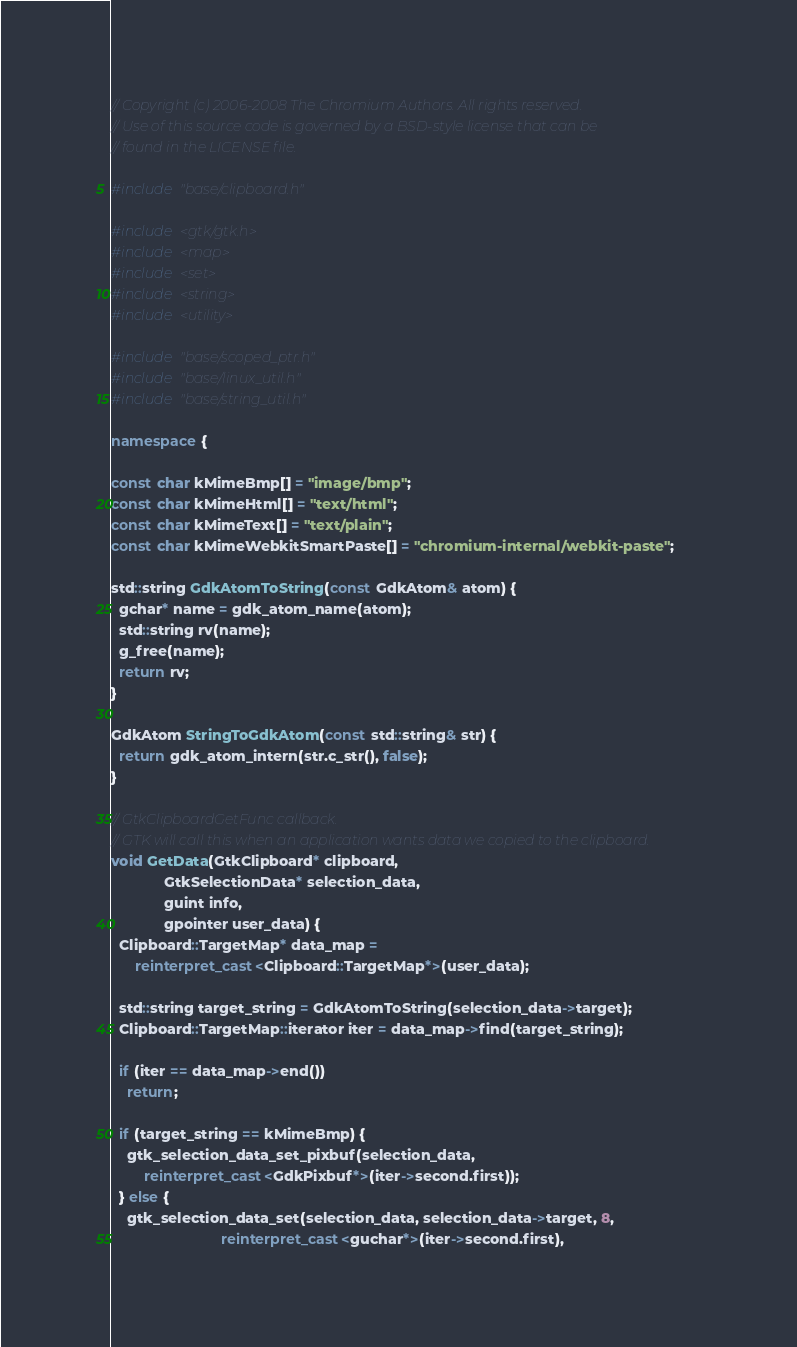<code> <loc_0><loc_0><loc_500><loc_500><_C++_>// Copyright (c) 2006-2008 The Chromium Authors. All rights reserved.
// Use of this source code is governed by a BSD-style license that can be
// found in the LICENSE file.

#include "base/clipboard.h"

#include <gtk/gtk.h>
#include <map>
#include <set>
#include <string>
#include <utility>

#include "base/scoped_ptr.h"
#include "base/linux_util.h"
#include "base/string_util.h"

namespace {

const char kMimeBmp[] = "image/bmp";
const char kMimeHtml[] = "text/html";
const char kMimeText[] = "text/plain";
const char kMimeWebkitSmartPaste[] = "chromium-internal/webkit-paste";

std::string GdkAtomToString(const GdkAtom& atom) {
  gchar* name = gdk_atom_name(atom);
  std::string rv(name);
  g_free(name);
  return rv;
}

GdkAtom StringToGdkAtom(const std::string& str) {
  return gdk_atom_intern(str.c_str(), false);
}

// GtkClipboardGetFunc callback.
// GTK will call this when an application wants data we copied to the clipboard.
void GetData(GtkClipboard* clipboard,
             GtkSelectionData* selection_data,
             guint info,
             gpointer user_data) {
  Clipboard::TargetMap* data_map =
      reinterpret_cast<Clipboard::TargetMap*>(user_data);

  std::string target_string = GdkAtomToString(selection_data->target);
  Clipboard::TargetMap::iterator iter = data_map->find(target_string);

  if (iter == data_map->end())
    return;

  if (target_string == kMimeBmp) {
    gtk_selection_data_set_pixbuf(selection_data,
        reinterpret_cast<GdkPixbuf*>(iter->second.first));
  } else {
    gtk_selection_data_set(selection_data, selection_data->target, 8,
                           reinterpret_cast<guchar*>(iter->second.first),</code> 